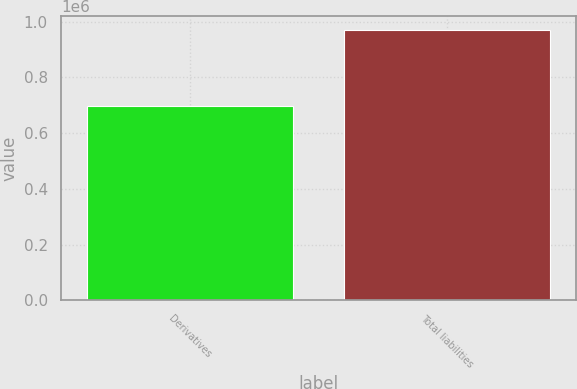Convert chart. <chart><loc_0><loc_0><loc_500><loc_500><bar_chart><fcel>Derivatives<fcel>Total liabilities<nl><fcel>698941<fcel>970982<nl></chart> 